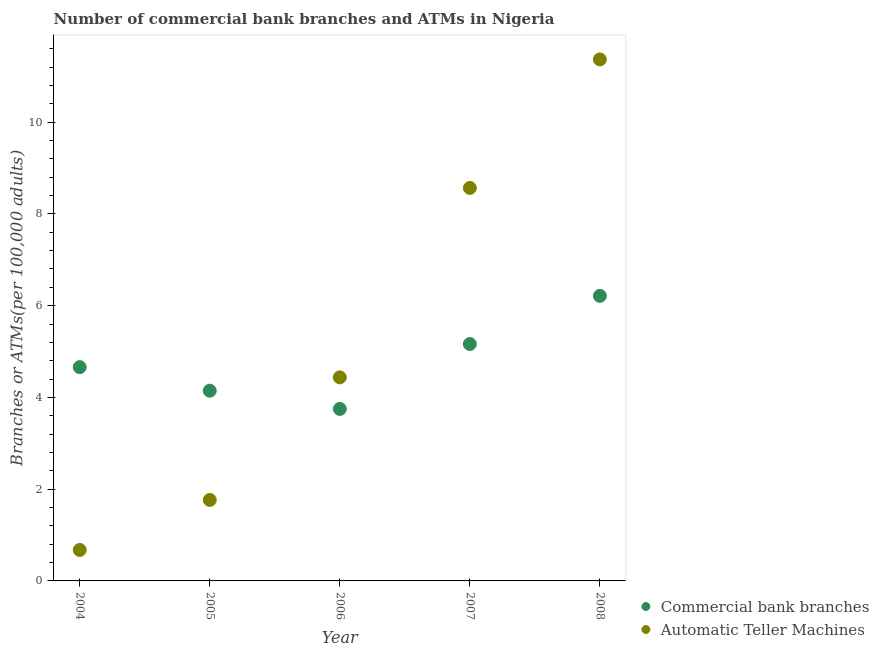How many different coloured dotlines are there?
Offer a very short reply. 2. What is the number of commercal bank branches in 2005?
Provide a succinct answer. 4.15. Across all years, what is the maximum number of commercal bank branches?
Offer a terse response. 6.21. Across all years, what is the minimum number of atms?
Your answer should be very brief. 0.68. In which year was the number of atms maximum?
Offer a very short reply. 2008. What is the total number of commercal bank branches in the graph?
Your answer should be very brief. 23.94. What is the difference between the number of commercal bank branches in 2004 and that in 2006?
Offer a very short reply. 0.91. What is the difference between the number of atms in 2005 and the number of commercal bank branches in 2004?
Offer a terse response. -2.9. What is the average number of commercal bank branches per year?
Offer a terse response. 4.79. In the year 2008, what is the difference between the number of atms and number of commercal bank branches?
Offer a terse response. 5.16. What is the ratio of the number of commercal bank branches in 2004 to that in 2005?
Provide a succinct answer. 1.12. Is the difference between the number of atms in 2007 and 2008 greater than the difference between the number of commercal bank branches in 2007 and 2008?
Give a very brief answer. No. What is the difference between the highest and the second highest number of atms?
Give a very brief answer. 2.8. What is the difference between the highest and the lowest number of commercal bank branches?
Keep it short and to the point. 2.46. In how many years, is the number of commercal bank branches greater than the average number of commercal bank branches taken over all years?
Offer a terse response. 2. Is the sum of the number of commercal bank branches in 2006 and 2008 greater than the maximum number of atms across all years?
Provide a short and direct response. No. How many years are there in the graph?
Ensure brevity in your answer.  5. What is the difference between two consecutive major ticks on the Y-axis?
Your response must be concise. 2. Are the values on the major ticks of Y-axis written in scientific E-notation?
Offer a terse response. No. Does the graph contain grids?
Provide a succinct answer. No. How are the legend labels stacked?
Provide a succinct answer. Vertical. What is the title of the graph?
Make the answer very short. Number of commercial bank branches and ATMs in Nigeria. What is the label or title of the Y-axis?
Keep it short and to the point. Branches or ATMs(per 100,0 adults). What is the Branches or ATMs(per 100,000 adults) of Commercial bank branches in 2004?
Your answer should be very brief. 4.66. What is the Branches or ATMs(per 100,000 adults) of Automatic Teller Machines in 2004?
Give a very brief answer. 0.68. What is the Branches or ATMs(per 100,000 adults) in Commercial bank branches in 2005?
Provide a short and direct response. 4.15. What is the Branches or ATMs(per 100,000 adults) in Automatic Teller Machines in 2005?
Your answer should be compact. 1.77. What is the Branches or ATMs(per 100,000 adults) of Commercial bank branches in 2006?
Offer a terse response. 3.75. What is the Branches or ATMs(per 100,000 adults) of Automatic Teller Machines in 2006?
Ensure brevity in your answer.  4.44. What is the Branches or ATMs(per 100,000 adults) in Commercial bank branches in 2007?
Your response must be concise. 5.16. What is the Branches or ATMs(per 100,000 adults) in Automatic Teller Machines in 2007?
Ensure brevity in your answer.  8.57. What is the Branches or ATMs(per 100,000 adults) in Commercial bank branches in 2008?
Your answer should be very brief. 6.21. What is the Branches or ATMs(per 100,000 adults) in Automatic Teller Machines in 2008?
Ensure brevity in your answer.  11.37. Across all years, what is the maximum Branches or ATMs(per 100,000 adults) of Commercial bank branches?
Give a very brief answer. 6.21. Across all years, what is the maximum Branches or ATMs(per 100,000 adults) in Automatic Teller Machines?
Offer a terse response. 11.37. Across all years, what is the minimum Branches or ATMs(per 100,000 adults) in Commercial bank branches?
Your answer should be compact. 3.75. Across all years, what is the minimum Branches or ATMs(per 100,000 adults) of Automatic Teller Machines?
Give a very brief answer. 0.68. What is the total Branches or ATMs(per 100,000 adults) in Commercial bank branches in the graph?
Ensure brevity in your answer.  23.94. What is the total Branches or ATMs(per 100,000 adults) in Automatic Teller Machines in the graph?
Your answer should be very brief. 26.82. What is the difference between the Branches or ATMs(per 100,000 adults) in Commercial bank branches in 2004 and that in 2005?
Provide a succinct answer. 0.51. What is the difference between the Branches or ATMs(per 100,000 adults) of Automatic Teller Machines in 2004 and that in 2005?
Provide a short and direct response. -1.09. What is the difference between the Branches or ATMs(per 100,000 adults) in Commercial bank branches in 2004 and that in 2006?
Offer a very short reply. 0.91. What is the difference between the Branches or ATMs(per 100,000 adults) of Automatic Teller Machines in 2004 and that in 2006?
Provide a succinct answer. -3.76. What is the difference between the Branches or ATMs(per 100,000 adults) in Commercial bank branches in 2004 and that in 2007?
Ensure brevity in your answer.  -0.5. What is the difference between the Branches or ATMs(per 100,000 adults) in Automatic Teller Machines in 2004 and that in 2007?
Keep it short and to the point. -7.89. What is the difference between the Branches or ATMs(per 100,000 adults) of Commercial bank branches in 2004 and that in 2008?
Your answer should be compact. -1.55. What is the difference between the Branches or ATMs(per 100,000 adults) in Automatic Teller Machines in 2004 and that in 2008?
Provide a short and direct response. -10.69. What is the difference between the Branches or ATMs(per 100,000 adults) of Commercial bank branches in 2005 and that in 2006?
Make the answer very short. 0.4. What is the difference between the Branches or ATMs(per 100,000 adults) of Automatic Teller Machines in 2005 and that in 2006?
Provide a succinct answer. -2.67. What is the difference between the Branches or ATMs(per 100,000 adults) in Commercial bank branches in 2005 and that in 2007?
Give a very brief answer. -1.02. What is the difference between the Branches or ATMs(per 100,000 adults) in Automatic Teller Machines in 2005 and that in 2007?
Keep it short and to the point. -6.8. What is the difference between the Branches or ATMs(per 100,000 adults) in Commercial bank branches in 2005 and that in 2008?
Your answer should be very brief. -2.07. What is the difference between the Branches or ATMs(per 100,000 adults) in Automatic Teller Machines in 2005 and that in 2008?
Your answer should be compact. -9.6. What is the difference between the Branches or ATMs(per 100,000 adults) in Commercial bank branches in 2006 and that in 2007?
Keep it short and to the point. -1.41. What is the difference between the Branches or ATMs(per 100,000 adults) of Automatic Teller Machines in 2006 and that in 2007?
Your answer should be very brief. -4.13. What is the difference between the Branches or ATMs(per 100,000 adults) of Commercial bank branches in 2006 and that in 2008?
Keep it short and to the point. -2.46. What is the difference between the Branches or ATMs(per 100,000 adults) of Automatic Teller Machines in 2006 and that in 2008?
Keep it short and to the point. -6.93. What is the difference between the Branches or ATMs(per 100,000 adults) in Commercial bank branches in 2007 and that in 2008?
Ensure brevity in your answer.  -1.05. What is the difference between the Branches or ATMs(per 100,000 adults) in Automatic Teller Machines in 2007 and that in 2008?
Provide a succinct answer. -2.8. What is the difference between the Branches or ATMs(per 100,000 adults) of Commercial bank branches in 2004 and the Branches or ATMs(per 100,000 adults) of Automatic Teller Machines in 2005?
Give a very brief answer. 2.9. What is the difference between the Branches or ATMs(per 100,000 adults) in Commercial bank branches in 2004 and the Branches or ATMs(per 100,000 adults) in Automatic Teller Machines in 2006?
Offer a terse response. 0.22. What is the difference between the Branches or ATMs(per 100,000 adults) in Commercial bank branches in 2004 and the Branches or ATMs(per 100,000 adults) in Automatic Teller Machines in 2007?
Provide a short and direct response. -3.91. What is the difference between the Branches or ATMs(per 100,000 adults) in Commercial bank branches in 2004 and the Branches or ATMs(per 100,000 adults) in Automatic Teller Machines in 2008?
Your answer should be compact. -6.71. What is the difference between the Branches or ATMs(per 100,000 adults) in Commercial bank branches in 2005 and the Branches or ATMs(per 100,000 adults) in Automatic Teller Machines in 2006?
Provide a short and direct response. -0.29. What is the difference between the Branches or ATMs(per 100,000 adults) in Commercial bank branches in 2005 and the Branches or ATMs(per 100,000 adults) in Automatic Teller Machines in 2007?
Your answer should be very brief. -4.42. What is the difference between the Branches or ATMs(per 100,000 adults) of Commercial bank branches in 2005 and the Branches or ATMs(per 100,000 adults) of Automatic Teller Machines in 2008?
Provide a short and direct response. -7.22. What is the difference between the Branches or ATMs(per 100,000 adults) in Commercial bank branches in 2006 and the Branches or ATMs(per 100,000 adults) in Automatic Teller Machines in 2007?
Your answer should be compact. -4.82. What is the difference between the Branches or ATMs(per 100,000 adults) in Commercial bank branches in 2006 and the Branches or ATMs(per 100,000 adults) in Automatic Teller Machines in 2008?
Provide a short and direct response. -7.62. What is the difference between the Branches or ATMs(per 100,000 adults) of Commercial bank branches in 2007 and the Branches or ATMs(per 100,000 adults) of Automatic Teller Machines in 2008?
Offer a terse response. -6.2. What is the average Branches or ATMs(per 100,000 adults) of Commercial bank branches per year?
Your answer should be very brief. 4.79. What is the average Branches or ATMs(per 100,000 adults) in Automatic Teller Machines per year?
Keep it short and to the point. 5.36. In the year 2004, what is the difference between the Branches or ATMs(per 100,000 adults) of Commercial bank branches and Branches or ATMs(per 100,000 adults) of Automatic Teller Machines?
Provide a short and direct response. 3.99. In the year 2005, what is the difference between the Branches or ATMs(per 100,000 adults) in Commercial bank branches and Branches or ATMs(per 100,000 adults) in Automatic Teller Machines?
Offer a terse response. 2.38. In the year 2006, what is the difference between the Branches or ATMs(per 100,000 adults) of Commercial bank branches and Branches or ATMs(per 100,000 adults) of Automatic Teller Machines?
Offer a very short reply. -0.69. In the year 2007, what is the difference between the Branches or ATMs(per 100,000 adults) of Commercial bank branches and Branches or ATMs(per 100,000 adults) of Automatic Teller Machines?
Provide a short and direct response. -3.4. In the year 2008, what is the difference between the Branches or ATMs(per 100,000 adults) in Commercial bank branches and Branches or ATMs(per 100,000 adults) in Automatic Teller Machines?
Provide a short and direct response. -5.16. What is the ratio of the Branches or ATMs(per 100,000 adults) of Commercial bank branches in 2004 to that in 2005?
Offer a terse response. 1.12. What is the ratio of the Branches or ATMs(per 100,000 adults) of Automatic Teller Machines in 2004 to that in 2005?
Your response must be concise. 0.38. What is the ratio of the Branches or ATMs(per 100,000 adults) of Commercial bank branches in 2004 to that in 2006?
Make the answer very short. 1.24. What is the ratio of the Branches or ATMs(per 100,000 adults) of Automatic Teller Machines in 2004 to that in 2006?
Keep it short and to the point. 0.15. What is the ratio of the Branches or ATMs(per 100,000 adults) in Commercial bank branches in 2004 to that in 2007?
Your answer should be very brief. 0.9. What is the ratio of the Branches or ATMs(per 100,000 adults) of Automatic Teller Machines in 2004 to that in 2007?
Offer a terse response. 0.08. What is the ratio of the Branches or ATMs(per 100,000 adults) of Commercial bank branches in 2004 to that in 2008?
Offer a terse response. 0.75. What is the ratio of the Branches or ATMs(per 100,000 adults) in Automatic Teller Machines in 2004 to that in 2008?
Give a very brief answer. 0.06. What is the ratio of the Branches or ATMs(per 100,000 adults) in Commercial bank branches in 2005 to that in 2006?
Give a very brief answer. 1.11. What is the ratio of the Branches or ATMs(per 100,000 adults) in Automatic Teller Machines in 2005 to that in 2006?
Your answer should be compact. 0.4. What is the ratio of the Branches or ATMs(per 100,000 adults) of Commercial bank branches in 2005 to that in 2007?
Give a very brief answer. 0.8. What is the ratio of the Branches or ATMs(per 100,000 adults) in Automatic Teller Machines in 2005 to that in 2007?
Your response must be concise. 0.21. What is the ratio of the Branches or ATMs(per 100,000 adults) in Commercial bank branches in 2005 to that in 2008?
Make the answer very short. 0.67. What is the ratio of the Branches or ATMs(per 100,000 adults) of Automatic Teller Machines in 2005 to that in 2008?
Your answer should be very brief. 0.16. What is the ratio of the Branches or ATMs(per 100,000 adults) of Commercial bank branches in 2006 to that in 2007?
Make the answer very short. 0.73. What is the ratio of the Branches or ATMs(per 100,000 adults) of Automatic Teller Machines in 2006 to that in 2007?
Offer a very short reply. 0.52. What is the ratio of the Branches or ATMs(per 100,000 adults) in Commercial bank branches in 2006 to that in 2008?
Provide a succinct answer. 0.6. What is the ratio of the Branches or ATMs(per 100,000 adults) in Automatic Teller Machines in 2006 to that in 2008?
Give a very brief answer. 0.39. What is the ratio of the Branches or ATMs(per 100,000 adults) of Commercial bank branches in 2007 to that in 2008?
Offer a terse response. 0.83. What is the ratio of the Branches or ATMs(per 100,000 adults) of Automatic Teller Machines in 2007 to that in 2008?
Make the answer very short. 0.75. What is the difference between the highest and the second highest Branches or ATMs(per 100,000 adults) in Commercial bank branches?
Offer a very short reply. 1.05. What is the difference between the highest and the second highest Branches or ATMs(per 100,000 adults) of Automatic Teller Machines?
Make the answer very short. 2.8. What is the difference between the highest and the lowest Branches or ATMs(per 100,000 adults) in Commercial bank branches?
Your answer should be very brief. 2.46. What is the difference between the highest and the lowest Branches or ATMs(per 100,000 adults) of Automatic Teller Machines?
Provide a succinct answer. 10.69. 